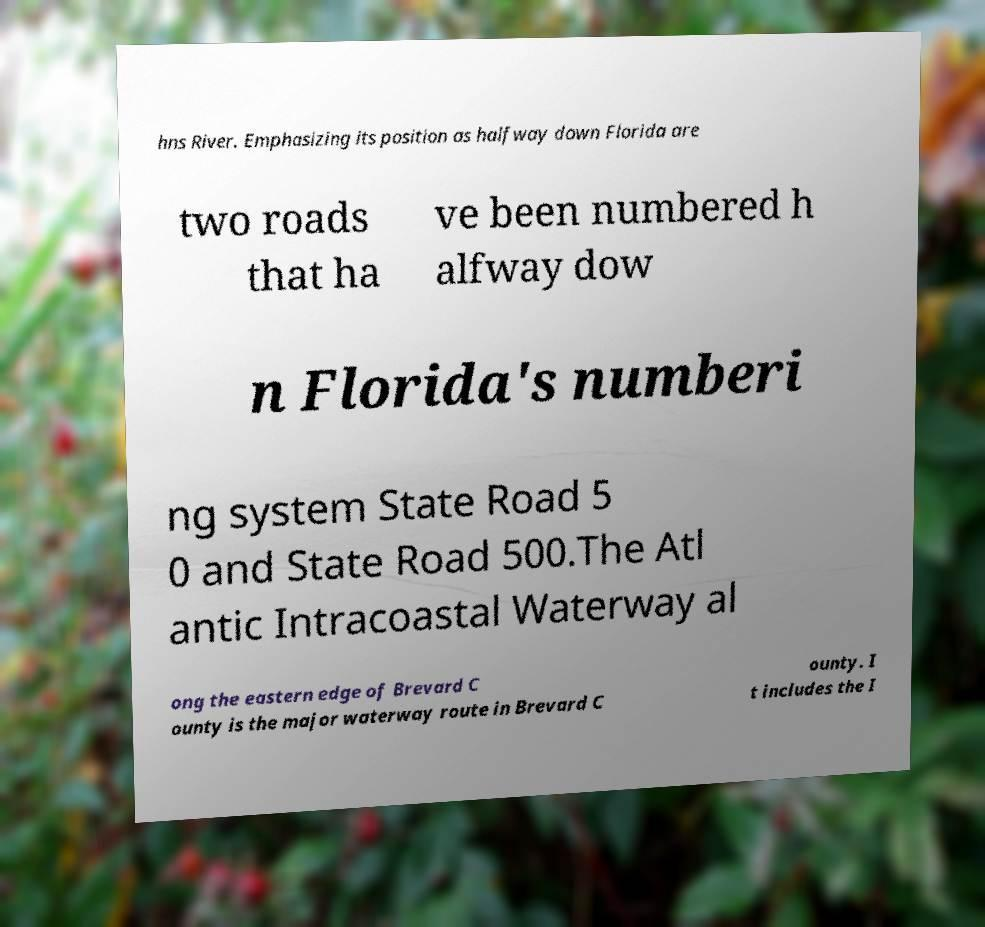Please read and relay the text visible in this image. What does it say? hns River. Emphasizing its position as halfway down Florida are two roads that ha ve been numbered h alfway dow n Florida's numberi ng system State Road 5 0 and State Road 500.The Atl antic Intracoastal Waterway al ong the eastern edge of Brevard C ounty is the major waterway route in Brevard C ounty. I t includes the I 